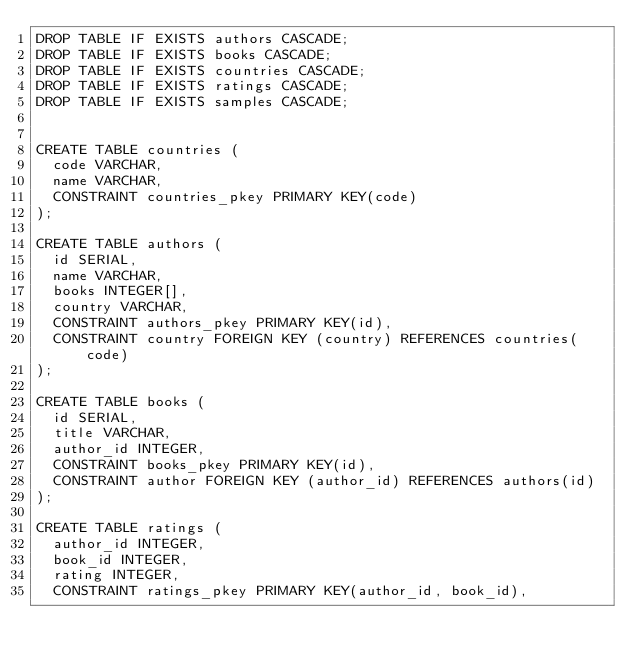<code> <loc_0><loc_0><loc_500><loc_500><_SQL_>DROP TABLE IF EXISTS authors CASCADE;
DROP TABLE IF EXISTS books CASCADE;
DROP TABLE IF EXISTS countries CASCADE;
DROP TABLE IF EXISTS ratings CASCADE;
DROP TABLE IF EXISTS samples CASCADE;


CREATE TABLE countries (
  code VARCHAR,
  name VARCHAR,
  CONSTRAINT countries_pkey PRIMARY KEY(code)
);

CREATE TABLE authors (
  id SERIAL,
  name VARCHAR,
  books INTEGER[],
  country VARCHAR,
  CONSTRAINT authors_pkey PRIMARY KEY(id),
  CONSTRAINT country FOREIGN KEY (country) REFERENCES countries(code)
);

CREATE TABLE books (
  id SERIAL,
  title VARCHAR,
  author_id INTEGER,
  CONSTRAINT books_pkey PRIMARY KEY(id),
  CONSTRAINT author FOREIGN KEY (author_id) REFERENCES authors(id)
);

CREATE TABLE ratings (
  author_id INTEGER,
  book_id INTEGER,
  rating INTEGER,
  CONSTRAINT ratings_pkey PRIMARY KEY(author_id, book_id),</code> 